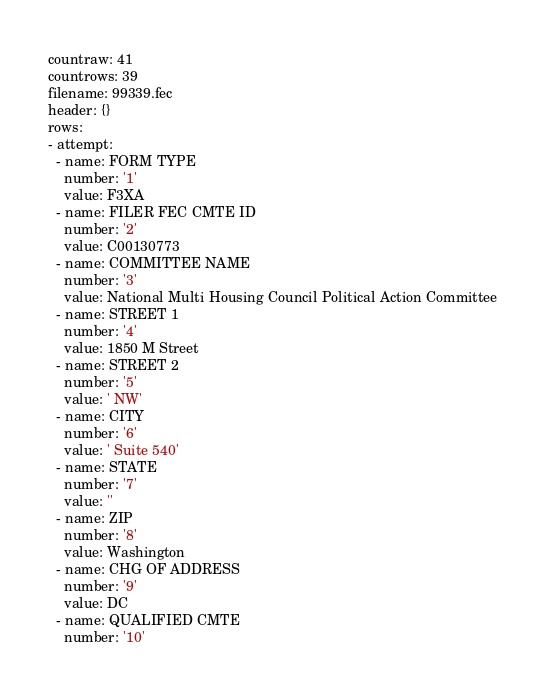Convert code to text. <code><loc_0><loc_0><loc_500><loc_500><_YAML_>countraw: 41
countrows: 39
filename: 99339.fec
header: {}
rows:
- attempt:
  - name: FORM TYPE
    number: '1'
    value: F3XA
  - name: FILER FEC CMTE ID
    number: '2'
    value: C00130773
  - name: COMMITTEE NAME
    number: '3'
    value: National Multi Housing Council Political Action Committee
  - name: STREET 1
    number: '4'
    value: 1850 M Street
  - name: STREET 2
    number: '5'
    value: ' NW'
  - name: CITY
    number: '6'
    value: ' Suite 540'
  - name: STATE
    number: '7'
    value: ''
  - name: ZIP
    number: '8'
    value: Washington
  - name: CHG OF ADDRESS
    number: '9'
    value: DC
  - name: QUALIFIED CMTE
    number: '10'</code> 